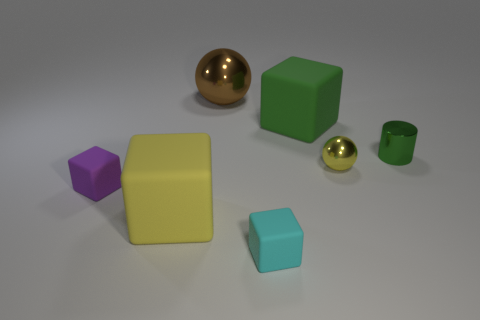There is a big matte thing behind the large yellow matte cube; is it the same color as the big sphere?
Make the answer very short. No. How many other purple metal cylinders have the same size as the cylinder?
Make the answer very short. 0. Is there a big matte ball that has the same color as the tiny metallic cylinder?
Provide a succinct answer. No. Do the tiny cyan cube and the large brown object have the same material?
Give a very brief answer. No. How many cyan matte objects are the same shape as the brown thing?
Give a very brief answer. 0. There is a yellow object that is the same material as the big brown ball; what is its shape?
Ensure brevity in your answer.  Sphere. What is the color of the tiny rubber object in front of the small thing that is left of the brown ball?
Your answer should be very brief. Cyan. Is the color of the small shiny sphere the same as the small metal cylinder?
Your response must be concise. No. There is a cube to the right of the tiny rubber object on the right side of the brown metallic ball; what is its material?
Provide a short and direct response. Rubber. There is a cyan object that is the same shape as the large green object; what is it made of?
Make the answer very short. Rubber. 